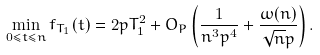Convert formula to latex. <formula><loc_0><loc_0><loc_500><loc_500>\min _ { 0 \leq t \leq n } f _ { T _ { 1 } } ( t ) = 2 p T _ { 1 } ^ { 2 } + O _ { P } \left ( \frac { 1 } { n ^ { 3 } p ^ { 4 } } + \frac { \omega ( n ) } { \sqrt { n } p } \right ) .</formula> 